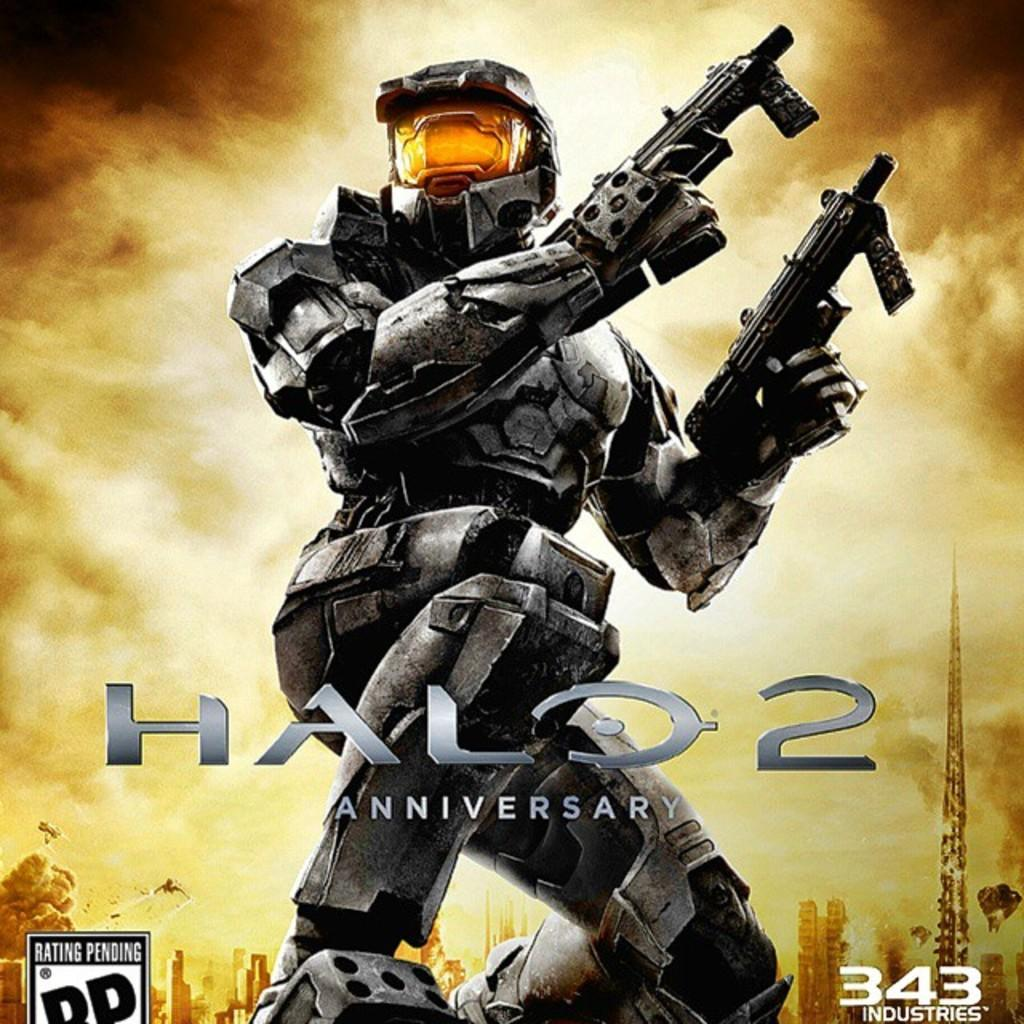<image>
Write a terse but informative summary of the picture. Halo 2 Anniversy shows a man in full gear with two guns. 